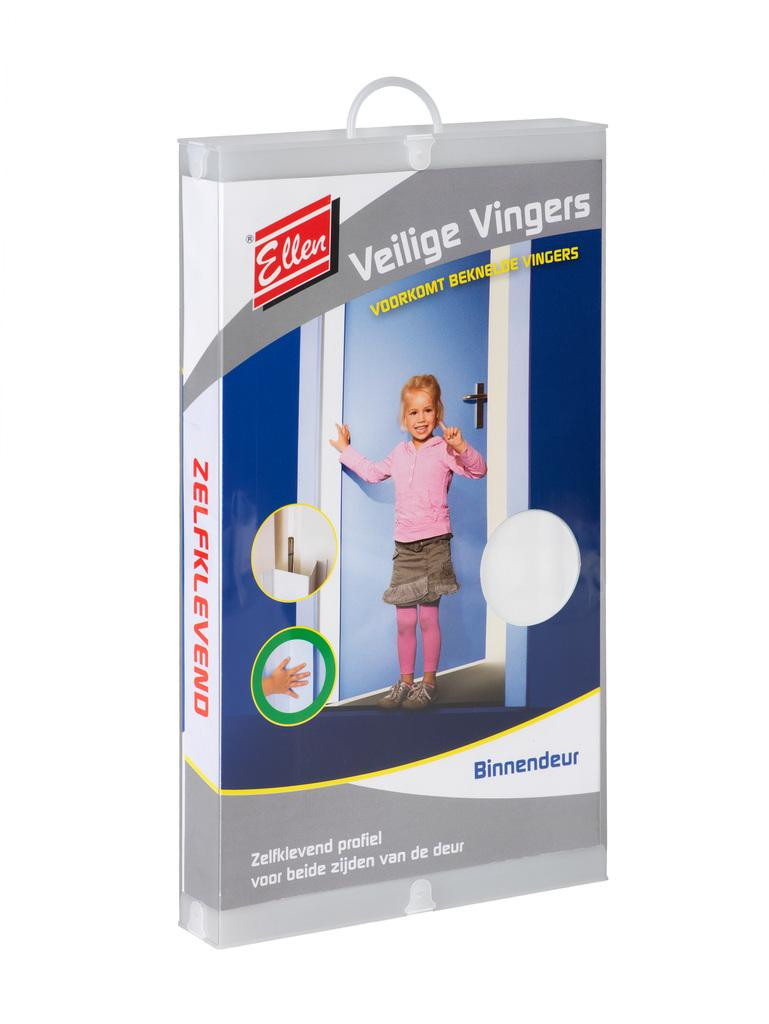What is the main subject in the center of the image? There is a bag in the center of the image. What type of yoke is being used to manage the pump in the image? There is no yoke or pump present in the image; it only features a bag. 